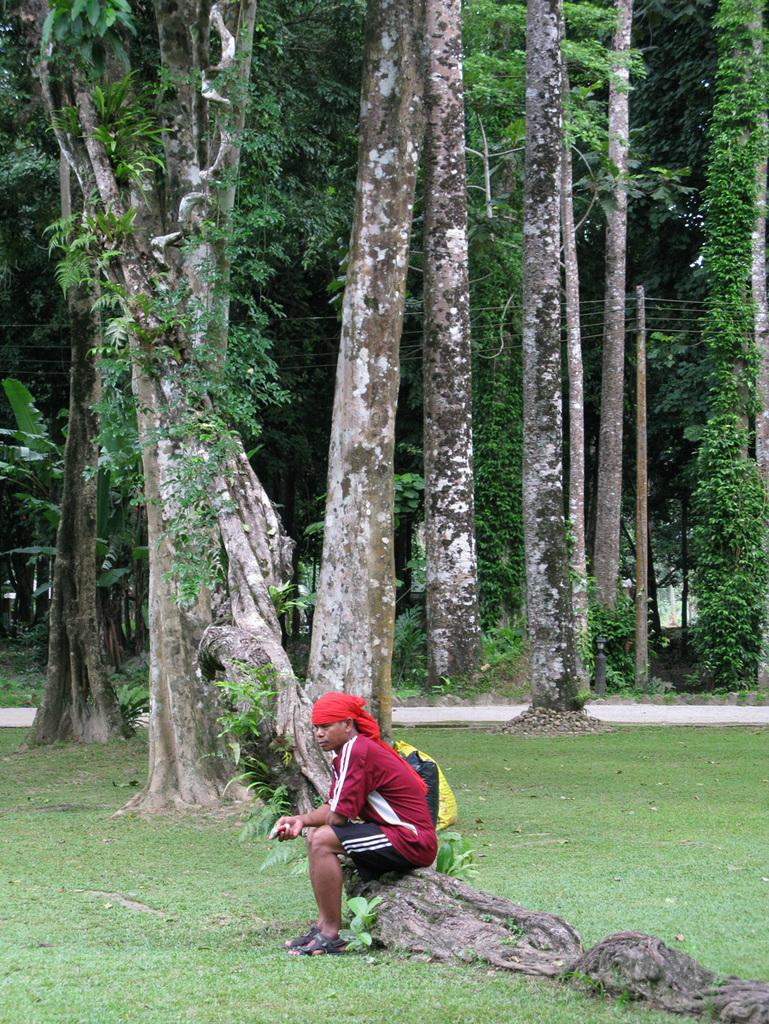What type of landscape is depicted in the image? There is a grassland in the image. What object can be seen on the grassland? There is a log on the grassland. What is the man in the image doing? A man is sitting on the log. What can be seen in the distance in the image? There are trees and a road in the background of the image. How many women are walking with mittens in the image? There are no women or mittens present in the image. 